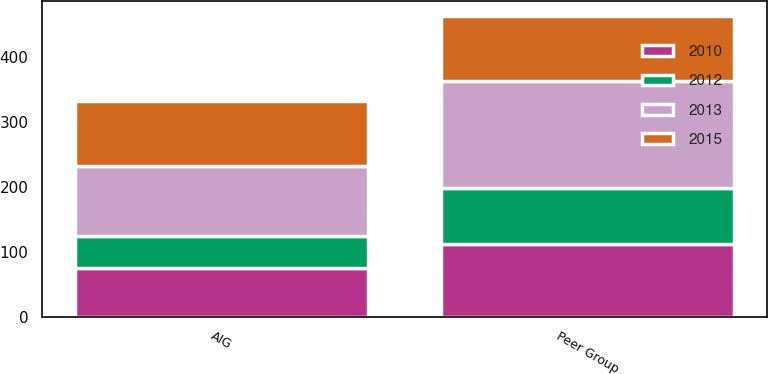<chart> <loc_0><loc_0><loc_500><loc_500><stacked_bar_chart><ecel><fcel>AIG<fcel>Peer Group<nl><fcel>2015<fcel>100<fcel>100<nl><fcel>2012<fcel>49.05<fcel>86.72<nl><fcel>2010<fcel>74.64<fcel>111.36<nl><fcel>2013<fcel>108.38<fcel>165.52<nl></chart> 